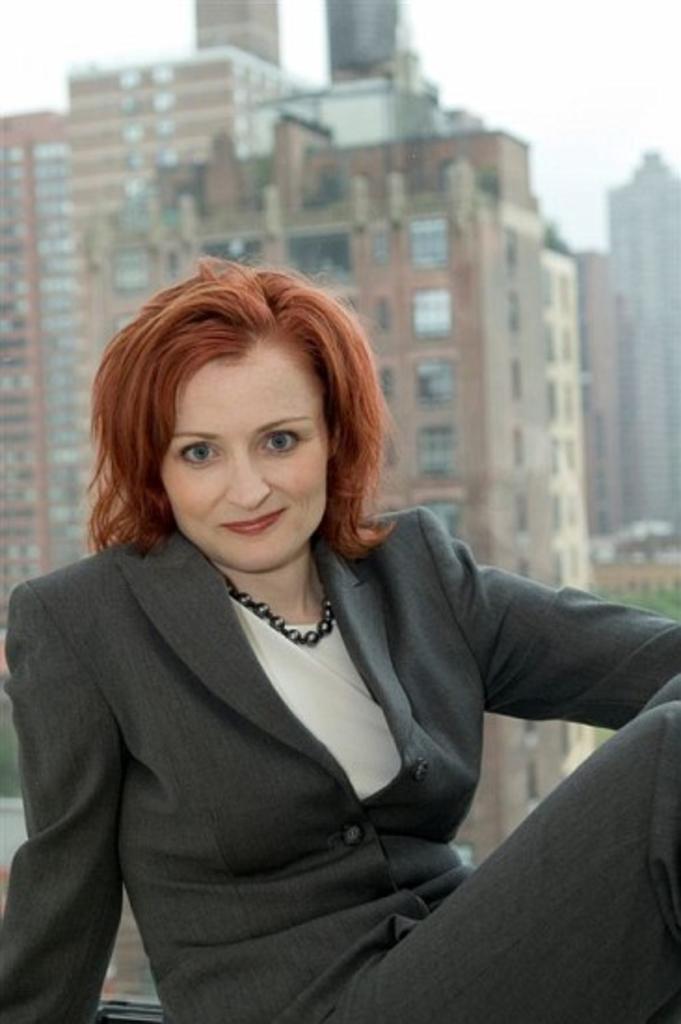In one or two sentences, can you explain what this image depicts? As we can see in the image in the front there is a woman wearing black color jacket. In the background there is a building and at the top there is a sky. 